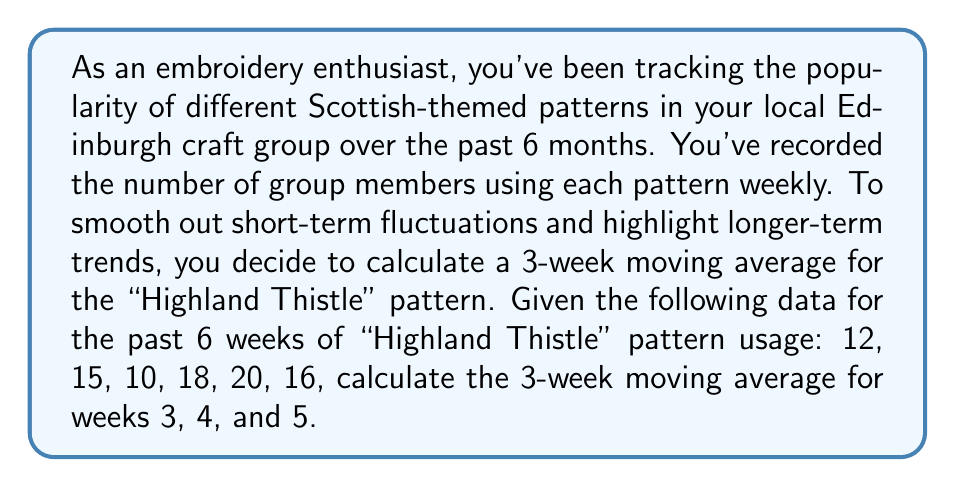Provide a solution to this math problem. To calculate a 3-week moving average, we need to follow these steps:

1. For each week, take the average of that week's value and the values of the two preceding weeks.
2. Move forward one week and repeat the process.

Let's calculate the moving averages:

For week 3:
$$ \text{Average} = \frac{12 + 15 + 10}{3} = \frac{37}{3} \approx 12.33 $$

For week 4:
$$ \text{Average} = \frac{15 + 10 + 18}{3} = \frac{43}{3} \approx 14.33 $$

For week 5:
$$ \text{Average} = \frac{10 + 18 + 20}{3} = \frac{48}{3} = 16 $$

These calculations smooth out the short-term fluctuations in the pattern's popularity, giving you a clearer idea of the trend over time. This method is particularly useful in embroidery trend analysis as it helps identify patterns that are consistently popular over a longer period, rather than those that might have a short-lived spike in interest.
Answer: The 3-week moving averages for weeks 3, 4, and 5 are approximately 12.33, 14.33, and 16, respectively. 